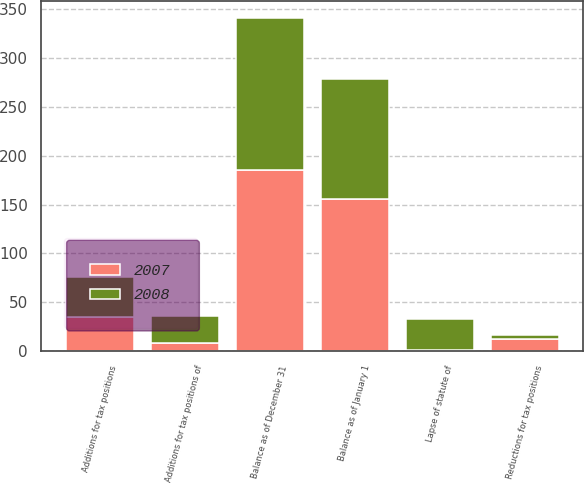<chart> <loc_0><loc_0><loc_500><loc_500><stacked_bar_chart><ecel><fcel>Balance as of January 1<fcel>Additions for tax positions<fcel>Additions for tax positions of<fcel>Reductions for tax positions<fcel>Lapse of statute of<fcel>Balance as of December 31<nl><fcel>2007<fcel>156.1<fcel>34.5<fcel>8.2<fcel>12.2<fcel>0.8<fcel>185.1<nl><fcel>2008<fcel>122.7<fcel>41.5<fcel>27.7<fcel>4<fcel>31.8<fcel>156.1<nl></chart> 